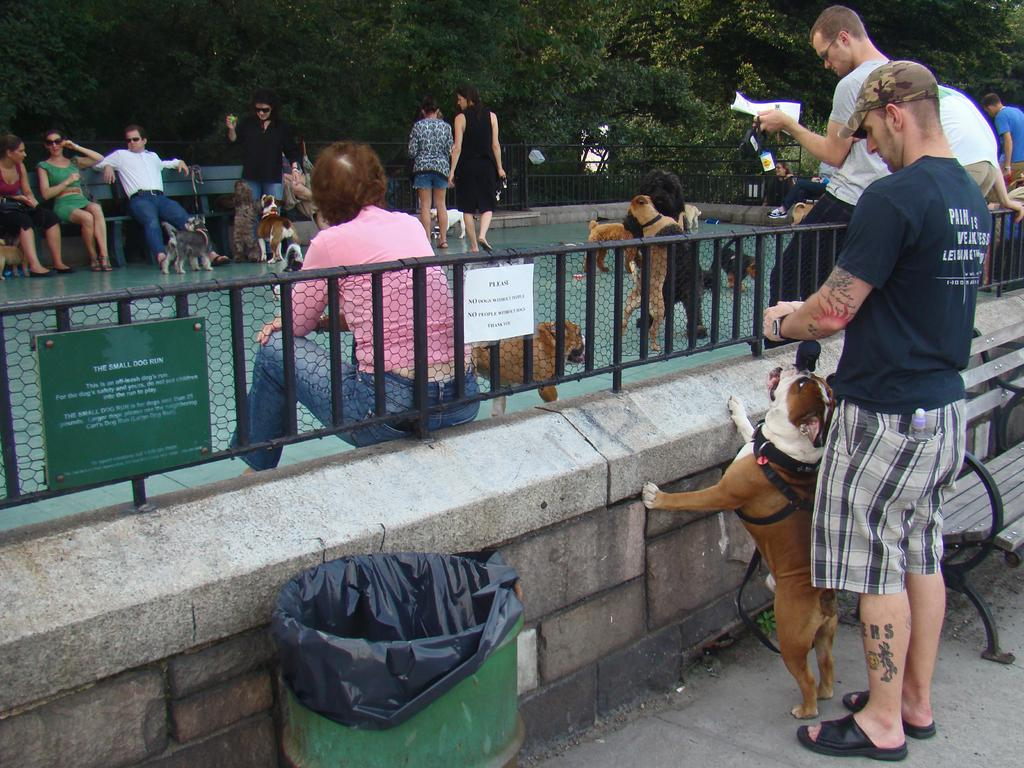What is the main feature of the image? There is an empty area in the image. What is happening in the empty area? Young dogs are playing in the empty area. Are there any people present in the image? Yes, people are sitting around the area where the dogs are playing. Can you describe the brown dog in the image? There is a brown dog in the image, and a man is standing behind it. What type of grape is being used to create destruction in the image? There is no grape present in the image, and no destruction is taking place. 